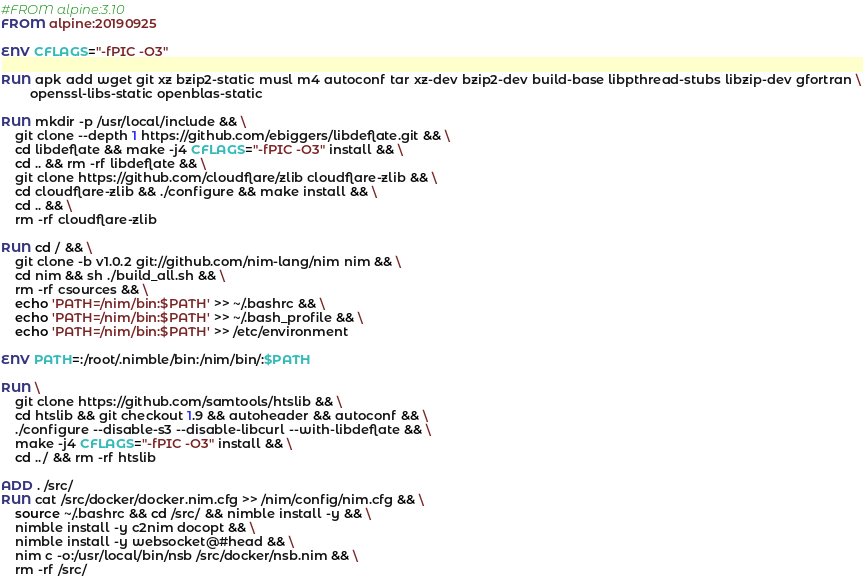Convert code to text. <code><loc_0><loc_0><loc_500><loc_500><_Dockerfile_>#FROM alpine:3.10
FROM alpine:20190925

ENV CFLAGS="-fPIC -O3"

RUN apk add wget git xz bzip2-static musl m4 autoconf tar xz-dev bzip2-dev build-base libpthread-stubs libzip-dev gfortran \
	    openssl-libs-static openblas-static

RUN mkdir -p /usr/local/include && \
    git clone --depth 1 https://github.com/ebiggers/libdeflate.git && \
    cd libdeflate && make -j4 CFLAGS="-fPIC -O3" install && \
    cd .. && rm -rf libdeflate && \
    git clone https://github.com/cloudflare/zlib cloudflare-zlib && \
    cd cloudflare-zlib && ./configure && make install && \
    cd .. && \
    rm -rf cloudflare-zlib

RUN cd / && \
    git clone -b v1.0.2 git://github.com/nim-lang/nim nim && \
    cd nim && sh ./build_all.sh && \
    rm -rf csources && \
    echo 'PATH=/nim/bin:$PATH' >> ~/.bashrc && \
    echo 'PATH=/nim/bin:$PATH' >> ~/.bash_profile && \
    echo 'PATH=/nim/bin:$PATH' >> /etc/environment 

ENV PATH=:/root/.nimble/bin:/nim/bin/:$PATH	

RUN \
    git clone https://github.com/samtools/htslib && \
    cd htslib && git checkout 1.9 && autoheader && autoconf && \
    ./configure --disable-s3 --disable-libcurl --with-libdeflate && \
    make -j4 CFLAGS="-fPIC -O3" install && \
    cd ../ && rm -rf htslib

ADD . /src/
RUN cat /src/docker/docker.nim.cfg >> /nim/config/nim.cfg && \
    source ~/.bashrc && cd /src/ && nimble install -y && \
    nimble install -y c2nim docopt && \
    nimble install -y websocket@#head && \
    nim c -o:/usr/local/bin/nsb /src/docker/nsb.nim && \
    rm -rf /src/

</code> 